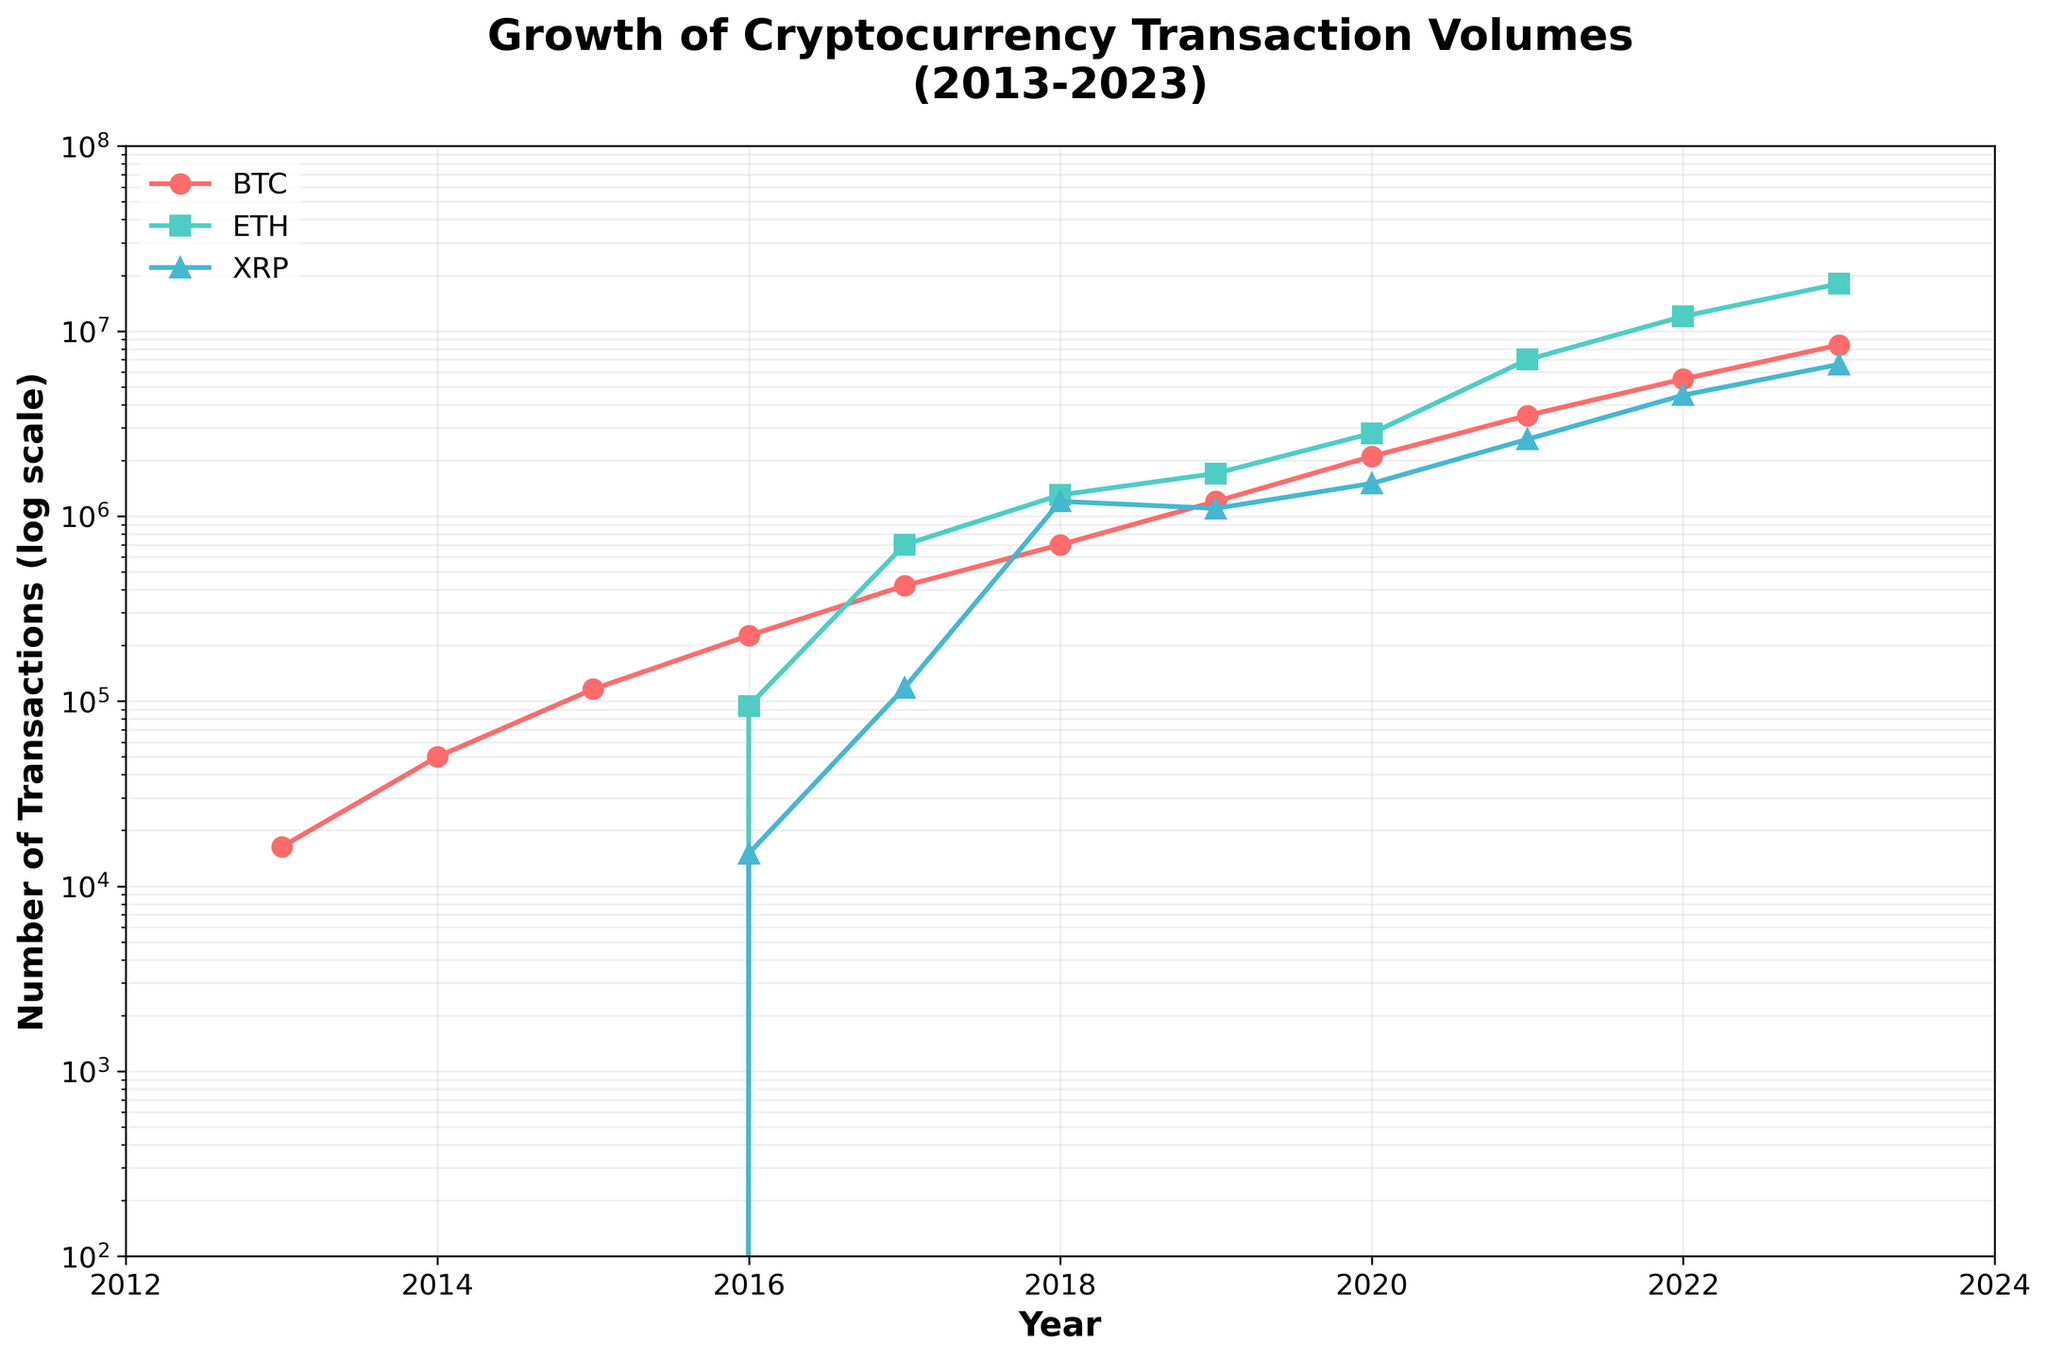What's the title of the figure? The title of the figure is written at the top of the plot. It reads "Growth of Cryptocurrency Transaction Volumes (2013-2023)."
Answer: Growth of Cryptocurrency Transaction Volumes (2013-2023) What are the colors representing Bitcoin, Ethereum, and Ripple transactions? The colors of the plot lines represent different cryptocurrencies. Bitcoin transactions are in red, Ethereum in teal, and Ripple in blue.
Answer: Bitcoin: red, Ethereum: teal, Ripple: blue In what year did Ethereum transactions first appear in the data? Looking at the data points for Ethereum, there are no transactions before 2016, so we infer that Ethereum transactions first appear in 2016.
Answer: 2016 What is the range of the y-axis in the log scale? The y-axis range can be determined by observing the axis limits. In this plot, the y-axis ranges from 100 (10^2) to 10 million (10^8).
Answer: 100 to 10 million Between which years did Bitcoin transactions increase from approximately 700,000 to around 1,200,000? By following the plotted points for Bitcoin transactions, the increase from around 700,000 to 1,200,000 occurred between 2018 and 2019.
Answer: 2018 to 2019 How many major grid lines does the y-axis have? The major grid lines on the y-axis are 100, 1,000, 10,000, 100,000, 1,000,000, and 10,000,000, totaling six major grid lines.
Answer: 6 Which year shows the highest number of Ethereum transactions and how many? The highest number of Ethereum transactions can be seen at the peak in 2023, with approximately 18,000,000 transactions.
Answer: 2023, 18,000,000 Compare the total number of transactions for all three cryptocurrencies in 2021. Which one had the highest and which one had the lowest? Adding up the number of transactions for each cryptocurrency in 2021: Bitcoin had 3,500,000, Ethereum 7,000,000, and Ripple 2,600,000. Ethereum had the highest, and Ripple had the lowest number of transactions.
Answer: Highest: Ethereum, Lowest: Ripple What is the percentage increase in Bitcoin transactions from 2017 to 2019? Bitcoin transactions in 2017 were 420,000 and in 2019 were 1,200,000. The percentage increase = ((1,200,000 - 420,000) / 420,000) * 100 = 185.71%.
Answer: 185.71% Estimate the average annual growth rate of Ripple transactions from 2016 to 2023. For Ripple transactions in 2016, 2017, 2020 and 2023: 15,000, 118,000, 1,500,000, and 6,600,000 respectively. The average annual growth rate can be approximated as (6600000/15000)^(1/7) - 1 ≈ 0.872 or 87.2%.
Answer: 87.2% 